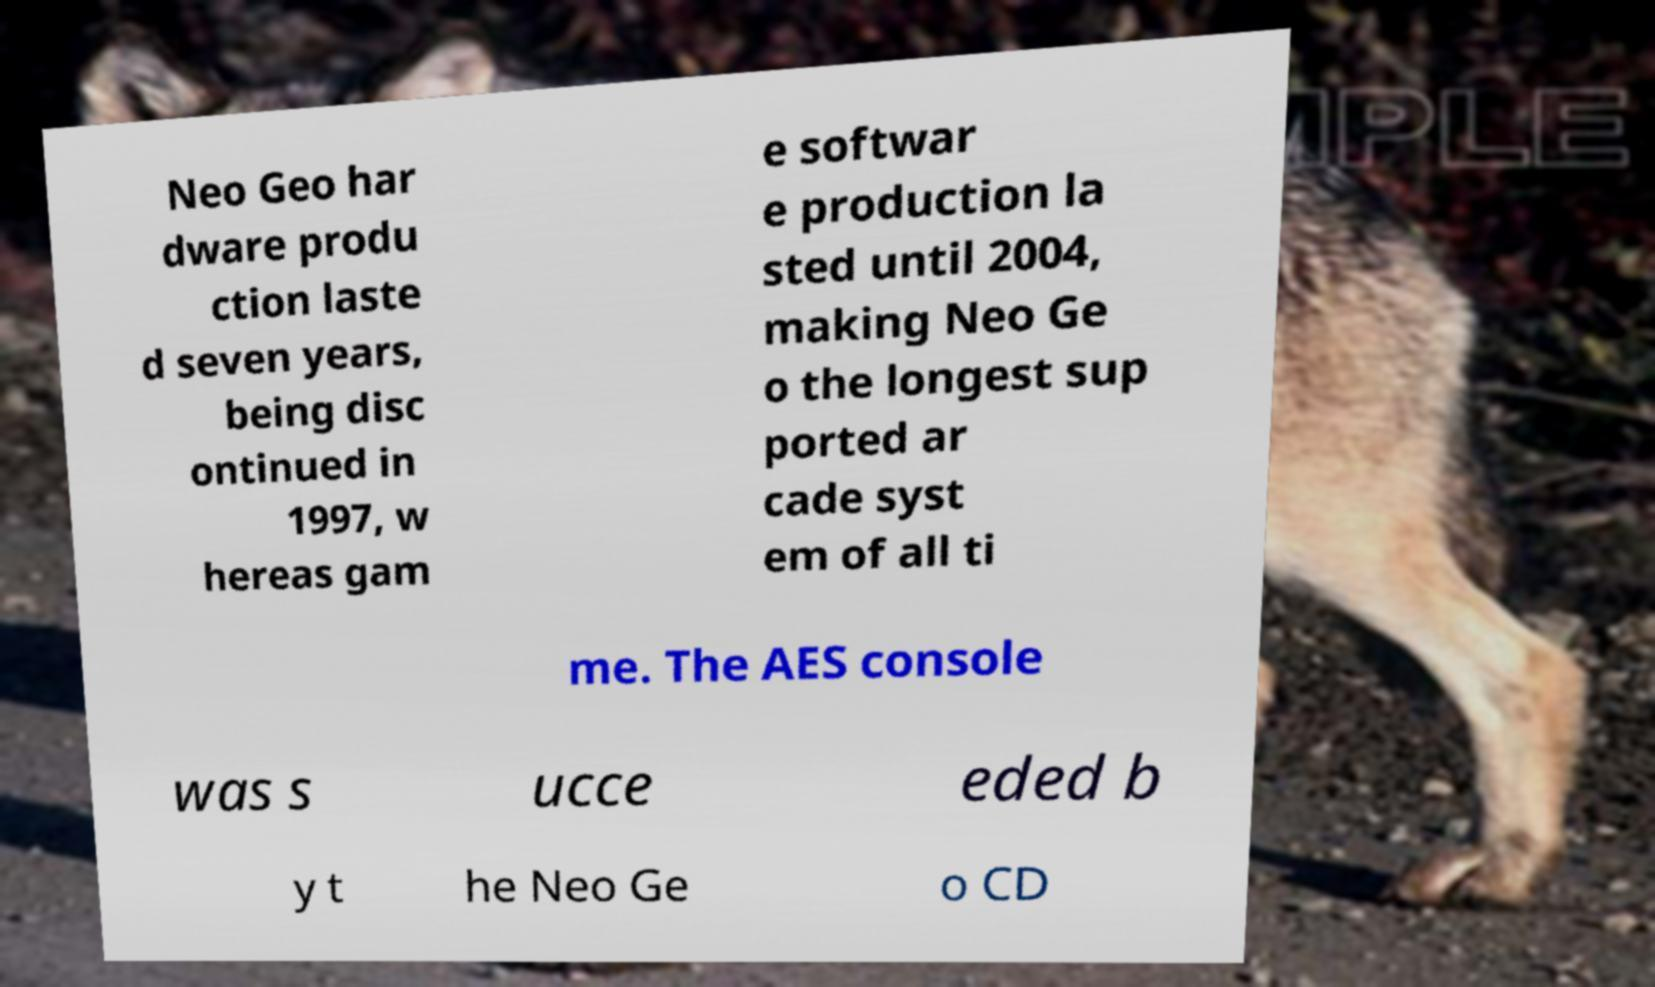Can you accurately transcribe the text from the provided image for me? Neo Geo har dware produ ction laste d seven years, being disc ontinued in 1997, w hereas gam e softwar e production la sted until 2004, making Neo Ge o the longest sup ported ar cade syst em of all ti me. The AES console was s ucce eded b y t he Neo Ge o CD 